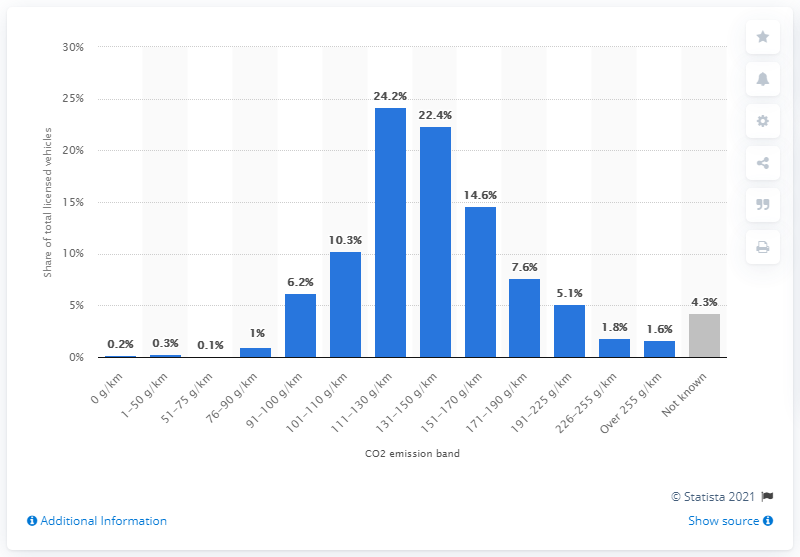Highlight a few significant elements in this photo. According to recent data, only 0.2% of passenger cars in the UK have zero emissions. Approximately 1.6% of licensed cars in the UK fall into the highest emission band, which is over 255 grams of CO2 per kilometer. 